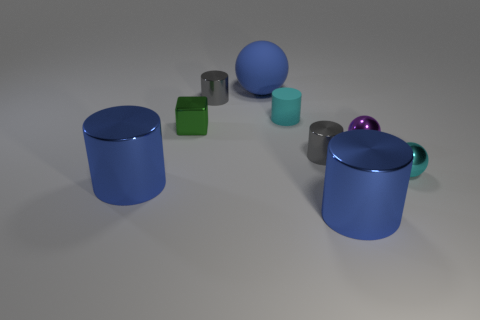Is there any other thing that has the same shape as the green thing?
Ensure brevity in your answer.  No. How many large blue rubber things have the same shape as the tiny purple shiny thing?
Your answer should be very brief. 1. What material is the cylinder that is on the left side of the blue matte sphere and in front of the cyan cylinder?
Offer a very short reply. Metal. Is the tiny cyan sphere made of the same material as the tiny cube?
Ensure brevity in your answer.  Yes. What number of small metal balls are there?
Give a very brief answer. 2. What color is the big shiny cylinder to the left of the large thing to the right of the big blue object that is behind the small cyan ball?
Give a very brief answer. Blue. Is the color of the large rubber ball the same as the block?
Make the answer very short. No. What number of metallic objects are in front of the small cyan metal ball and to the right of the purple metallic ball?
Your answer should be compact. 0. What number of rubber objects are small cyan spheres or tiny purple objects?
Keep it short and to the point. 0. What material is the cylinder in front of the large blue shiny cylinder that is to the left of the big ball?
Ensure brevity in your answer.  Metal. 